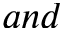Convert formula to latex. <formula><loc_0><loc_0><loc_500><loc_500>a n d</formula> 